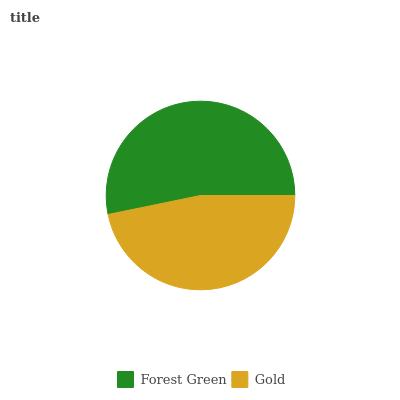Is Gold the minimum?
Answer yes or no. Yes. Is Forest Green the maximum?
Answer yes or no. Yes. Is Gold the maximum?
Answer yes or no. No. Is Forest Green greater than Gold?
Answer yes or no. Yes. Is Gold less than Forest Green?
Answer yes or no. Yes. Is Gold greater than Forest Green?
Answer yes or no. No. Is Forest Green less than Gold?
Answer yes or no. No. Is Forest Green the high median?
Answer yes or no. Yes. Is Gold the low median?
Answer yes or no. Yes. Is Gold the high median?
Answer yes or no. No. Is Forest Green the low median?
Answer yes or no. No. 